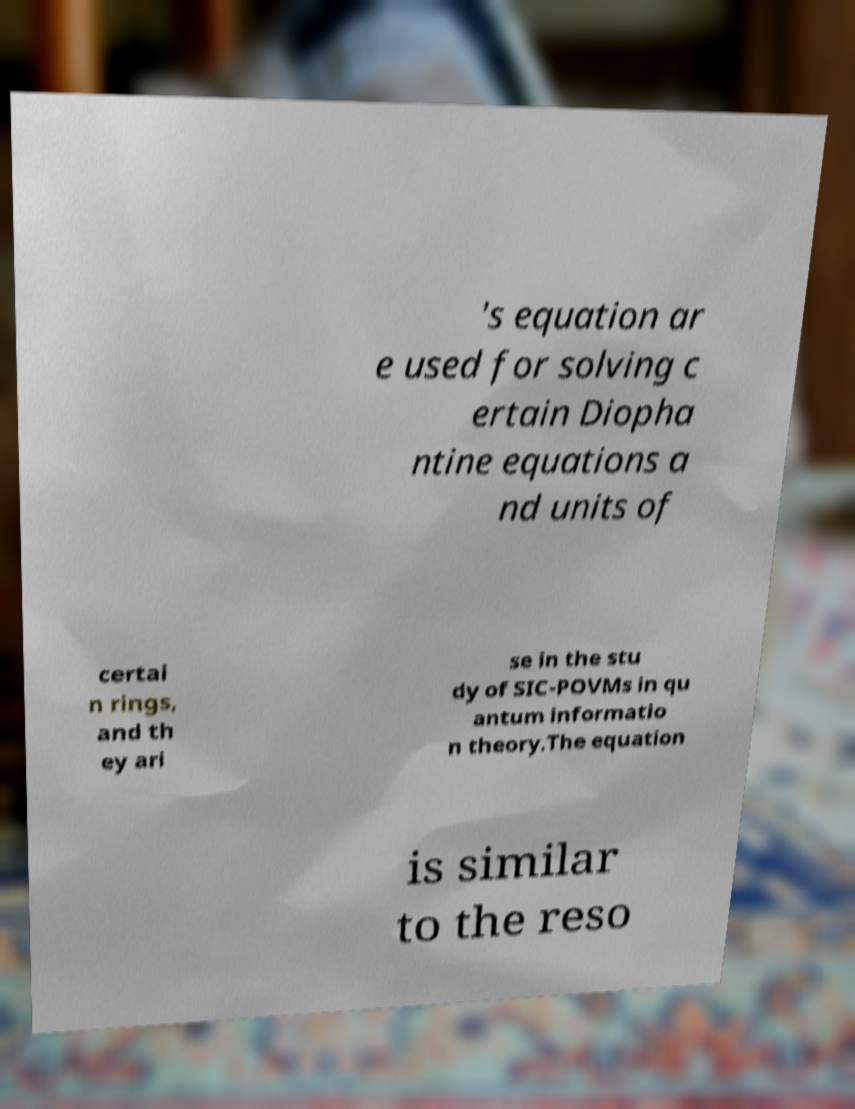What messages or text are displayed in this image? I need them in a readable, typed format. 's equation ar e used for solving c ertain Diopha ntine equations a nd units of certai n rings, and th ey ari se in the stu dy of SIC-POVMs in qu antum informatio n theory.The equation is similar to the reso 